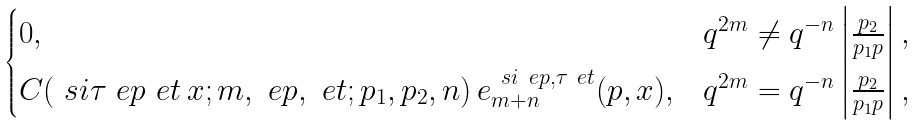<formula> <loc_0><loc_0><loc_500><loc_500>\begin{cases} 0 , & q ^ { 2 m } \neq q ^ { - n } \left | \frac { p _ { 2 } } { p _ { 1 } p } \right | , \\ C ( \ s i \tau \ e p \ e t \, x ; m , \ e p , \ e t ; p _ { 1 } , p _ { 2 } , n ) \, e _ { m + n } ^ { \ s i \ e p , \tau \ e t } ( p , x ) , & q ^ { 2 m } = q ^ { - n } \left | \frac { p _ { 2 } } { p _ { 1 } p } \right | , \end{cases}</formula> 